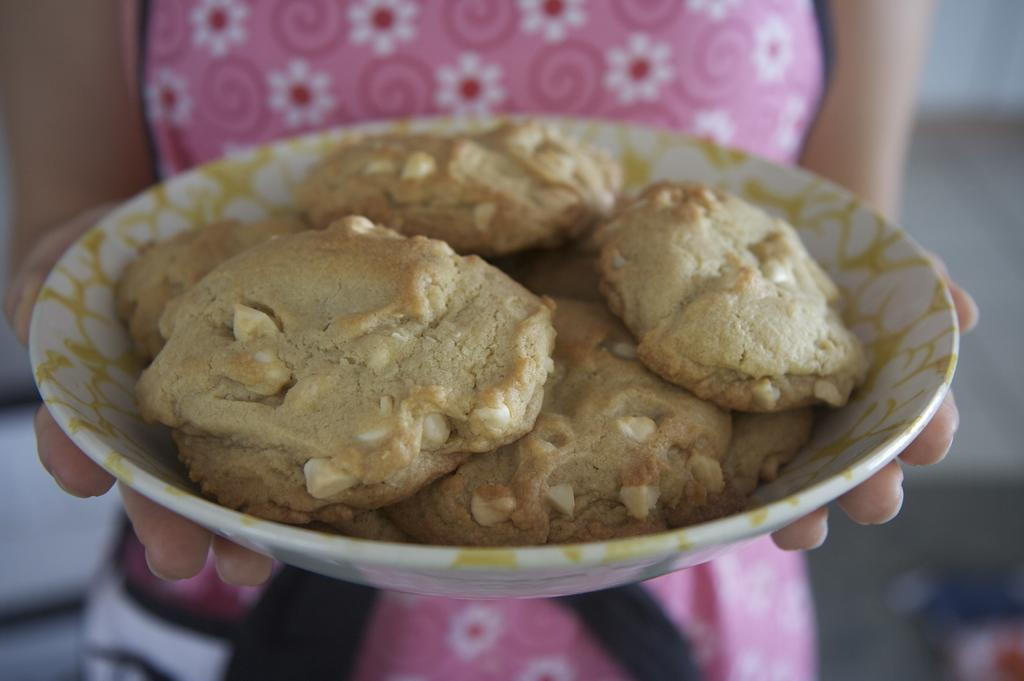What is the main subject of the image? There is a person in the image. What is the person holding in the image? The person is holding a bowl of cookies. What is the person wearing in the image? The person is wearing a pink dress. What type of cable can be seen connecting the person's tooth to the bowl of cookies? There is no cable present in the image, and the person's tooth is not connected to the bowl of cookies. 